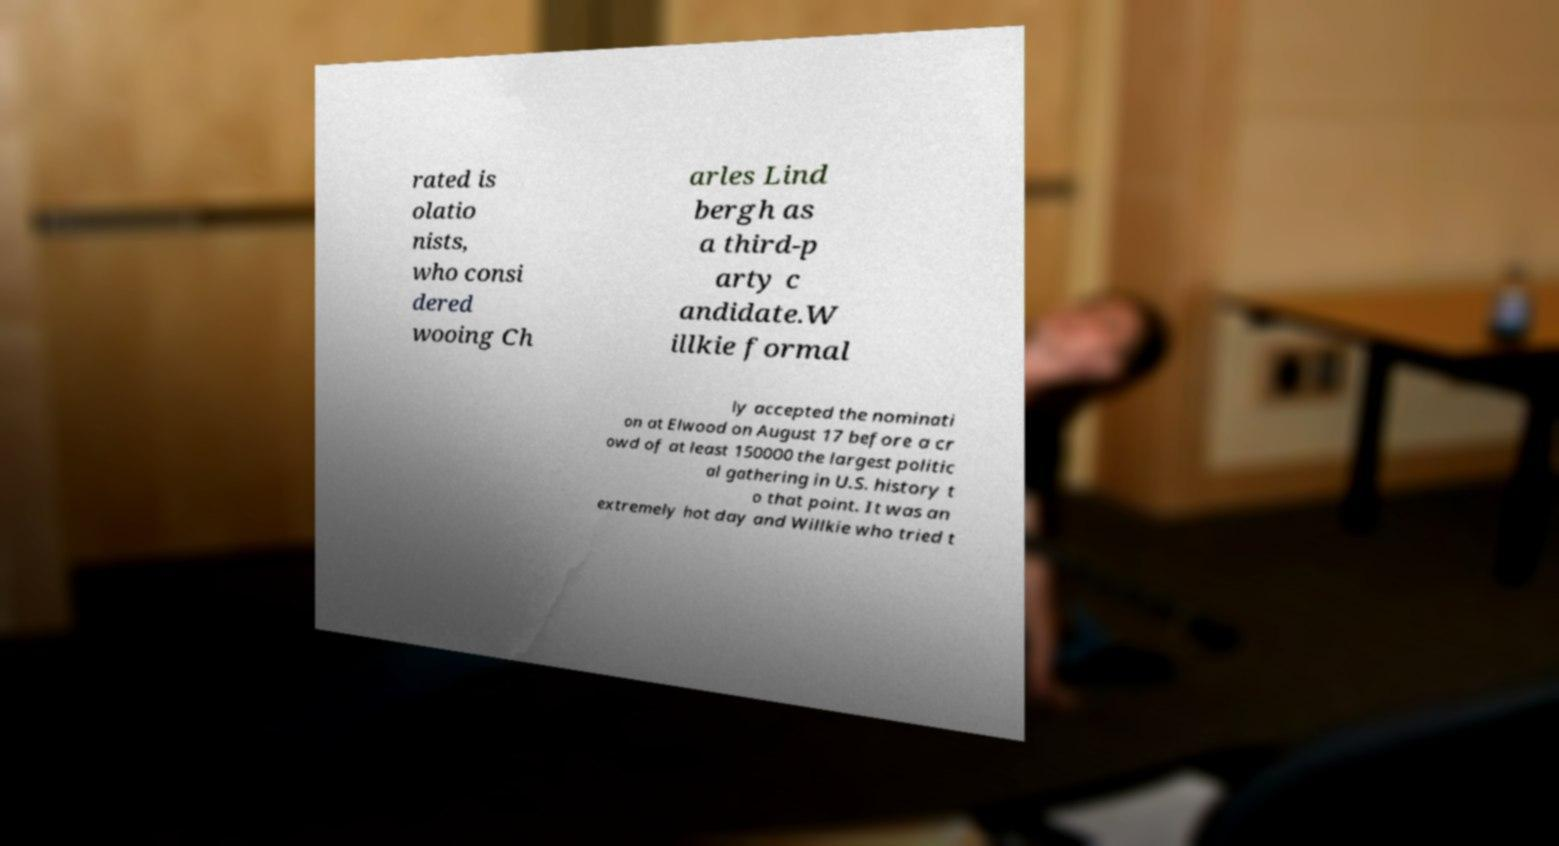What messages or text are displayed in this image? I need them in a readable, typed format. rated is olatio nists, who consi dered wooing Ch arles Lind bergh as a third-p arty c andidate.W illkie formal ly accepted the nominati on at Elwood on August 17 before a cr owd of at least 150000 the largest politic al gathering in U.S. history t o that point. It was an extremely hot day and Willkie who tried t 